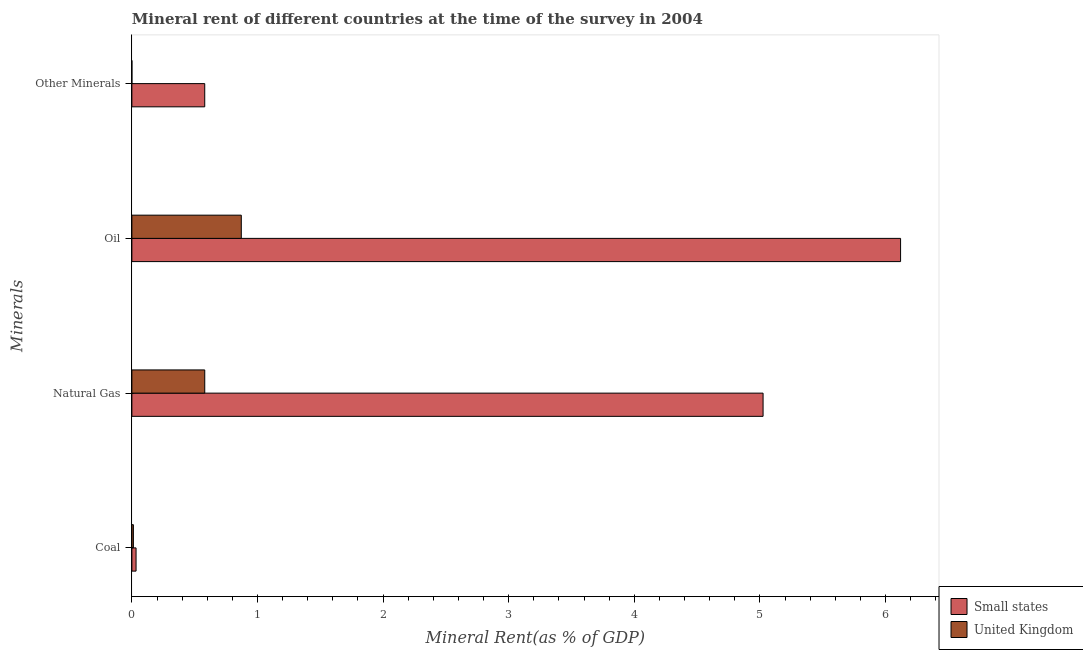How many different coloured bars are there?
Make the answer very short. 2. How many groups of bars are there?
Keep it short and to the point. 4. Are the number of bars per tick equal to the number of legend labels?
Give a very brief answer. Yes. How many bars are there on the 3rd tick from the bottom?
Your answer should be very brief. 2. What is the label of the 1st group of bars from the top?
Your answer should be very brief. Other Minerals. What is the oil rent in United Kingdom?
Offer a very short reply. 0.87. Across all countries, what is the maximum  rent of other minerals?
Offer a terse response. 0.58. Across all countries, what is the minimum natural gas rent?
Your answer should be very brief. 0.58. In which country was the oil rent maximum?
Provide a succinct answer. Small states. In which country was the natural gas rent minimum?
Provide a short and direct response. United Kingdom. What is the total oil rent in the graph?
Keep it short and to the point. 6.99. What is the difference between the coal rent in Small states and that in United Kingdom?
Your response must be concise. 0.02. What is the difference between the coal rent in Small states and the  rent of other minerals in United Kingdom?
Your response must be concise. 0.03. What is the average coal rent per country?
Offer a terse response. 0.02. What is the difference between the oil rent and  rent of other minerals in United Kingdom?
Offer a very short reply. 0.87. In how many countries, is the oil rent greater than 1.8 %?
Your response must be concise. 1. What is the ratio of the oil rent in United Kingdom to that in Small states?
Offer a terse response. 0.14. Is the coal rent in United Kingdom less than that in Small states?
Make the answer very short. Yes. What is the difference between the highest and the second highest natural gas rent?
Your response must be concise. 4.44. What is the difference between the highest and the lowest coal rent?
Provide a short and direct response. 0.02. In how many countries, is the  rent of other minerals greater than the average  rent of other minerals taken over all countries?
Your answer should be compact. 1. Is the sum of the coal rent in United Kingdom and Small states greater than the maximum natural gas rent across all countries?
Keep it short and to the point. No. Is it the case that in every country, the sum of the oil rent and coal rent is greater than the sum of  rent of other minerals and natural gas rent?
Offer a very short reply. Yes. What does the 2nd bar from the top in Other Minerals represents?
Make the answer very short. Small states. What does the 2nd bar from the bottom in Other Minerals represents?
Ensure brevity in your answer.  United Kingdom. How many bars are there?
Offer a very short reply. 8. Are all the bars in the graph horizontal?
Keep it short and to the point. Yes. What is the difference between two consecutive major ticks on the X-axis?
Give a very brief answer. 1. Does the graph contain any zero values?
Offer a terse response. No. How many legend labels are there?
Offer a terse response. 2. How are the legend labels stacked?
Your answer should be very brief. Vertical. What is the title of the graph?
Your answer should be very brief. Mineral rent of different countries at the time of the survey in 2004. What is the label or title of the X-axis?
Your answer should be very brief. Mineral Rent(as % of GDP). What is the label or title of the Y-axis?
Your response must be concise. Minerals. What is the Mineral Rent(as % of GDP) of Small states in Coal?
Your response must be concise. 0.03. What is the Mineral Rent(as % of GDP) in United Kingdom in Coal?
Your answer should be very brief. 0.01. What is the Mineral Rent(as % of GDP) of Small states in Natural Gas?
Ensure brevity in your answer.  5.02. What is the Mineral Rent(as % of GDP) in United Kingdom in Natural Gas?
Your answer should be compact. 0.58. What is the Mineral Rent(as % of GDP) in Small states in Oil?
Make the answer very short. 6.12. What is the Mineral Rent(as % of GDP) in United Kingdom in Oil?
Keep it short and to the point. 0.87. What is the Mineral Rent(as % of GDP) of Small states in Other Minerals?
Provide a succinct answer. 0.58. What is the Mineral Rent(as % of GDP) in United Kingdom in Other Minerals?
Provide a succinct answer. 6.19596915094659e-6. Across all Minerals, what is the maximum Mineral Rent(as % of GDP) in Small states?
Provide a succinct answer. 6.12. Across all Minerals, what is the maximum Mineral Rent(as % of GDP) of United Kingdom?
Make the answer very short. 0.87. Across all Minerals, what is the minimum Mineral Rent(as % of GDP) in Small states?
Give a very brief answer. 0.03. Across all Minerals, what is the minimum Mineral Rent(as % of GDP) of United Kingdom?
Your answer should be compact. 6.19596915094659e-6. What is the total Mineral Rent(as % of GDP) of Small states in the graph?
Keep it short and to the point. 11.76. What is the total Mineral Rent(as % of GDP) in United Kingdom in the graph?
Offer a very short reply. 1.46. What is the difference between the Mineral Rent(as % of GDP) of Small states in Coal and that in Natural Gas?
Your answer should be compact. -4.99. What is the difference between the Mineral Rent(as % of GDP) of United Kingdom in Coal and that in Natural Gas?
Offer a very short reply. -0.57. What is the difference between the Mineral Rent(as % of GDP) of Small states in Coal and that in Oil?
Make the answer very short. -6.09. What is the difference between the Mineral Rent(as % of GDP) in United Kingdom in Coal and that in Oil?
Offer a terse response. -0.86. What is the difference between the Mineral Rent(as % of GDP) in Small states in Coal and that in Other Minerals?
Your answer should be compact. -0.55. What is the difference between the Mineral Rent(as % of GDP) of United Kingdom in Coal and that in Other Minerals?
Your response must be concise. 0.01. What is the difference between the Mineral Rent(as % of GDP) in Small states in Natural Gas and that in Oil?
Provide a short and direct response. -1.09. What is the difference between the Mineral Rent(as % of GDP) in United Kingdom in Natural Gas and that in Oil?
Give a very brief answer. -0.29. What is the difference between the Mineral Rent(as % of GDP) of Small states in Natural Gas and that in Other Minerals?
Offer a very short reply. 4.44. What is the difference between the Mineral Rent(as % of GDP) of United Kingdom in Natural Gas and that in Other Minerals?
Keep it short and to the point. 0.58. What is the difference between the Mineral Rent(as % of GDP) in Small states in Oil and that in Other Minerals?
Provide a short and direct response. 5.54. What is the difference between the Mineral Rent(as % of GDP) in United Kingdom in Oil and that in Other Minerals?
Your answer should be compact. 0.87. What is the difference between the Mineral Rent(as % of GDP) of Small states in Coal and the Mineral Rent(as % of GDP) of United Kingdom in Natural Gas?
Provide a short and direct response. -0.55. What is the difference between the Mineral Rent(as % of GDP) in Small states in Coal and the Mineral Rent(as % of GDP) in United Kingdom in Oil?
Offer a terse response. -0.84. What is the difference between the Mineral Rent(as % of GDP) in Small states in Coal and the Mineral Rent(as % of GDP) in United Kingdom in Other Minerals?
Your response must be concise. 0.03. What is the difference between the Mineral Rent(as % of GDP) of Small states in Natural Gas and the Mineral Rent(as % of GDP) of United Kingdom in Oil?
Your answer should be very brief. 4.15. What is the difference between the Mineral Rent(as % of GDP) in Small states in Natural Gas and the Mineral Rent(as % of GDP) in United Kingdom in Other Minerals?
Ensure brevity in your answer.  5.02. What is the difference between the Mineral Rent(as % of GDP) of Small states in Oil and the Mineral Rent(as % of GDP) of United Kingdom in Other Minerals?
Provide a short and direct response. 6.12. What is the average Mineral Rent(as % of GDP) of Small states per Minerals?
Keep it short and to the point. 2.94. What is the average Mineral Rent(as % of GDP) in United Kingdom per Minerals?
Keep it short and to the point. 0.37. What is the difference between the Mineral Rent(as % of GDP) of Small states and Mineral Rent(as % of GDP) of United Kingdom in Coal?
Provide a short and direct response. 0.02. What is the difference between the Mineral Rent(as % of GDP) of Small states and Mineral Rent(as % of GDP) of United Kingdom in Natural Gas?
Provide a short and direct response. 4.44. What is the difference between the Mineral Rent(as % of GDP) of Small states and Mineral Rent(as % of GDP) of United Kingdom in Oil?
Offer a terse response. 5.25. What is the difference between the Mineral Rent(as % of GDP) in Small states and Mineral Rent(as % of GDP) in United Kingdom in Other Minerals?
Ensure brevity in your answer.  0.58. What is the ratio of the Mineral Rent(as % of GDP) in Small states in Coal to that in Natural Gas?
Give a very brief answer. 0.01. What is the ratio of the Mineral Rent(as % of GDP) of United Kingdom in Coal to that in Natural Gas?
Your answer should be very brief. 0.02. What is the ratio of the Mineral Rent(as % of GDP) of Small states in Coal to that in Oil?
Ensure brevity in your answer.  0.01. What is the ratio of the Mineral Rent(as % of GDP) in United Kingdom in Coal to that in Oil?
Your response must be concise. 0.01. What is the ratio of the Mineral Rent(as % of GDP) of Small states in Coal to that in Other Minerals?
Provide a succinct answer. 0.06. What is the ratio of the Mineral Rent(as % of GDP) of United Kingdom in Coal to that in Other Minerals?
Make the answer very short. 1951.23. What is the ratio of the Mineral Rent(as % of GDP) of Small states in Natural Gas to that in Oil?
Offer a very short reply. 0.82. What is the ratio of the Mineral Rent(as % of GDP) of United Kingdom in Natural Gas to that in Oil?
Ensure brevity in your answer.  0.67. What is the ratio of the Mineral Rent(as % of GDP) of Small states in Natural Gas to that in Other Minerals?
Offer a terse response. 8.66. What is the ratio of the Mineral Rent(as % of GDP) in United Kingdom in Natural Gas to that in Other Minerals?
Give a very brief answer. 9.36e+04. What is the ratio of the Mineral Rent(as % of GDP) of Small states in Oil to that in Other Minerals?
Keep it short and to the point. 10.55. What is the ratio of the Mineral Rent(as % of GDP) in United Kingdom in Oil to that in Other Minerals?
Your answer should be very brief. 1.41e+05. What is the difference between the highest and the second highest Mineral Rent(as % of GDP) in Small states?
Offer a very short reply. 1.09. What is the difference between the highest and the second highest Mineral Rent(as % of GDP) of United Kingdom?
Your response must be concise. 0.29. What is the difference between the highest and the lowest Mineral Rent(as % of GDP) of Small states?
Your answer should be very brief. 6.09. What is the difference between the highest and the lowest Mineral Rent(as % of GDP) in United Kingdom?
Provide a short and direct response. 0.87. 